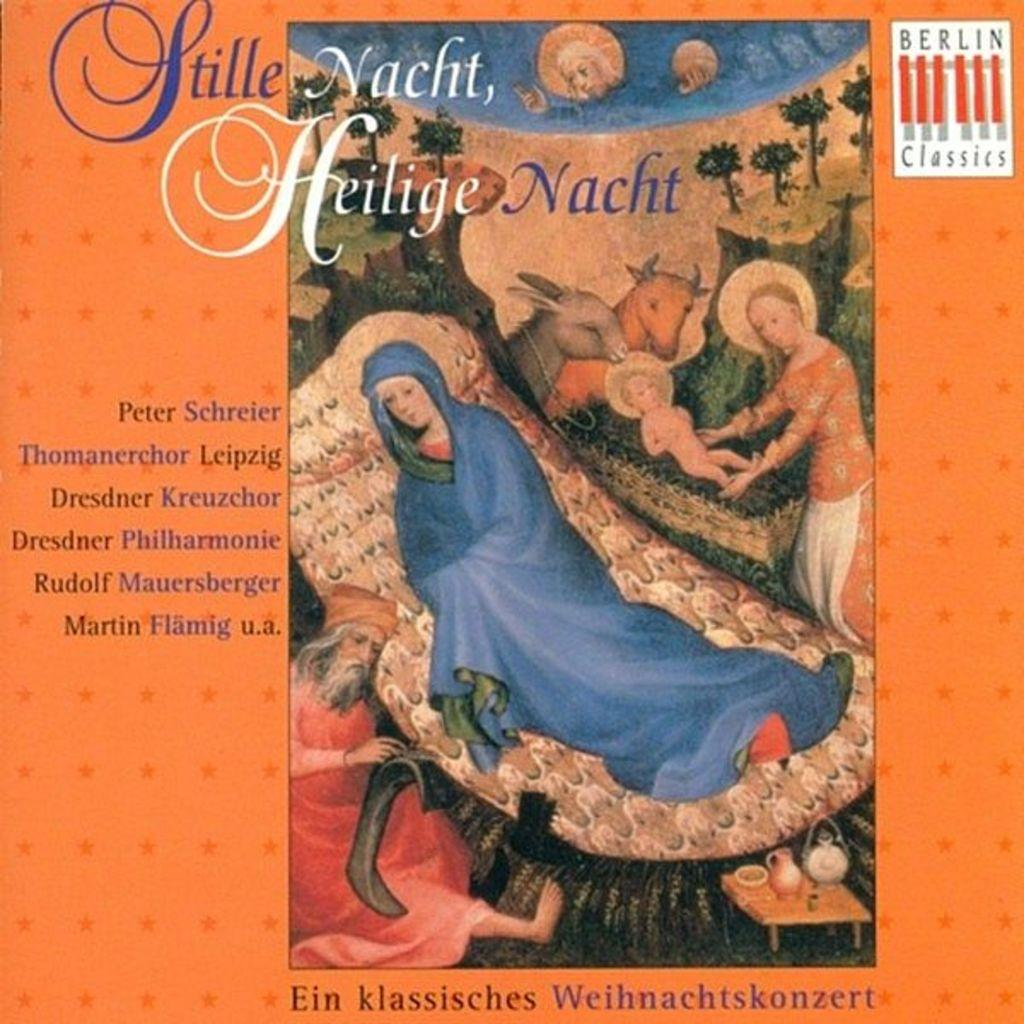<image>
Share a concise interpretation of the image provided. "Stille Nacht, Heilige Nacht", produced by Berlin Classics, is by Peter Schreier et. al. 